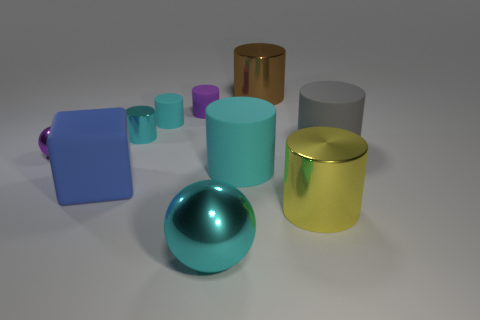How many other things are the same size as the block?
Provide a short and direct response. 5. What number of large objects are either blue rubber spheres or brown objects?
Provide a succinct answer. 1. Is the size of the cyan ball the same as the matte object that is in front of the big cyan cylinder?
Give a very brief answer. Yes. How many other things are the same shape as the blue matte object?
Provide a succinct answer. 0. There is a purple thing that is made of the same material as the cube; what is its shape?
Ensure brevity in your answer.  Cylinder. Are any red shiny objects visible?
Your answer should be compact. No. Is the number of matte cylinders left of the large brown metal thing less than the number of small purple shiny objects that are in front of the large gray cylinder?
Offer a very short reply. No. There is a purple object left of the large blue object; what is its shape?
Provide a succinct answer. Sphere. Are the large ball and the brown cylinder made of the same material?
Your answer should be very brief. Yes. Is there any other thing that is made of the same material as the brown thing?
Make the answer very short. Yes. 